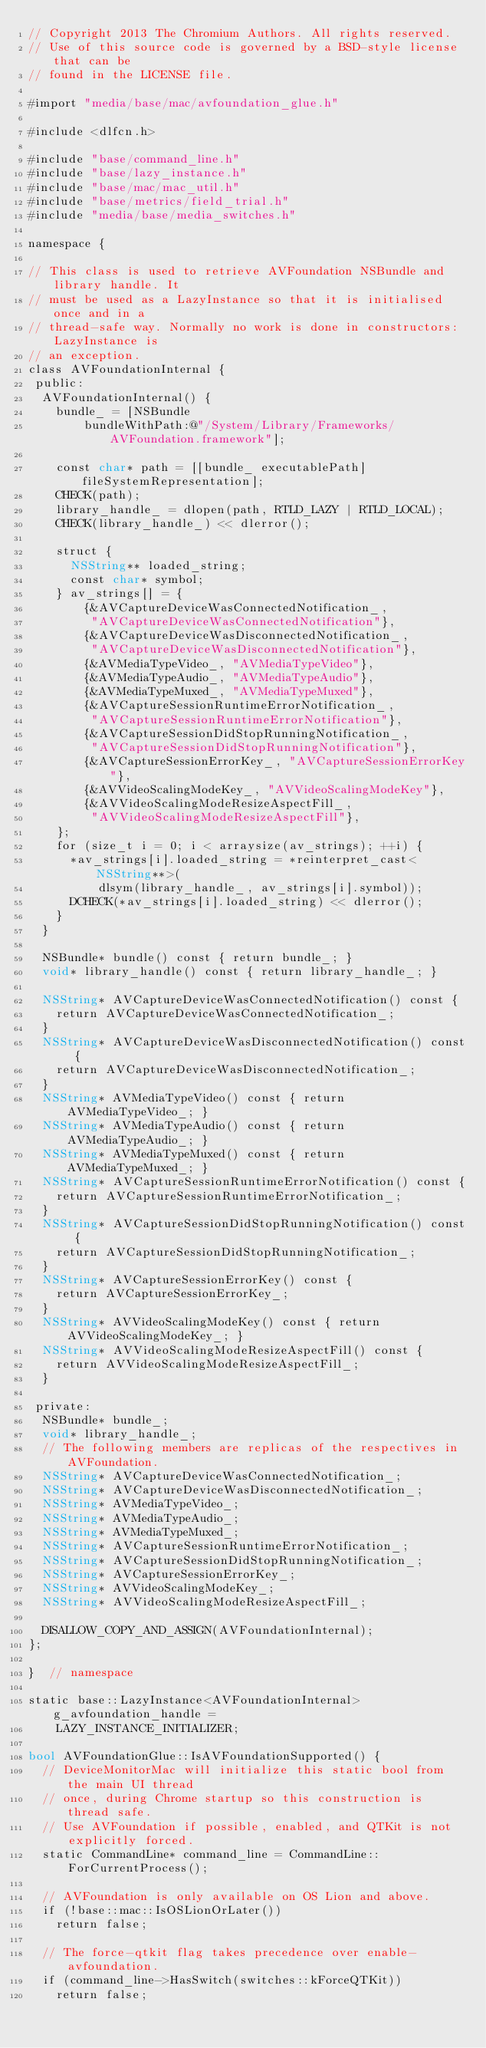<code> <loc_0><loc_0><loc_500><loc_500><_ObjectiveC_>// Copyright 2013 The Chromium Authors. All rights reserved.
// Use of this source code is governed by a BSD-style license that can be
// found in the LICENSE file.

#import "media/base/mac/avfoundation_glue.h"

#include <dlfcn.h>

#include "base/command_line.h"
#include "base/lazy_instance.h"
#include "base/mac/mac_util.h"
#include "base/metrics/field_trial.h"
#include "media/base/media_switches.h"

namespace {

// This class is used to retrieve AVFoundation NSBundle and library handle. It
// must be used as a LazyInstance so that it is initialised once and in a
// thread-safe way. Normally no work is done in constructors: LazyInstance is
// an exception.
class AVFoundationInternal {
 public:
  AVFoundationInternal() {
    bundle_ = [NSBundle
        bundleWithPath:@"/System/Library/Frameworks/AVFoundation.framework"];

    const char* path = [[bundle_ executablePath] fileSystemRepresentation];
    CHECK(path);
    library_handle_ = dlopen(path, RTLD_LAZY | RTLD_LOCAL);
    CHECK(library_handle_) << dlerror();

    struct {
      NSString** loaded_string;
      const char* symbol;
    } av_strings[] = {
        {&AVCaptureDeviceWasConnectedNotification_,
         "AVCaptureDeviceWasConnectedNotification"},
        {&AVCaptureDeviceWasDisconnectedNotification_,
         "AVCaptureDeviceWasDisconnectedNotification"},
        {&AVMediaTypeVideo_, "AVMediaTypeVideo"},
        {&AVMediaTypeAudio_, "AVMediaTypeAudio"},
        {&AVMediaTypeMuxed_, "AVMediaTypeMuxed"},
        {&AVCaptureSessionRuntimeErrorNotification_,
         "AVCaptureSessionRuntimeErrorNotification"},
        {&AVCaptureSessionDidStopRunningNotification_,
         "AVCaptureSessionDidStopRunningNotification"},
        {&AVCaptureSessionErrorKey_, "AVCaptureSessionErrorKey"},
        {&AVVideoScalingModeKey_, "AVVideoScalingModeKey"},
        {&AVVideoScalingModeResizeAspectFill_,
         "AVVideoScalingModeResizeAspectFill"},
    };
    for (size_t i = 0; i < arraysize(av_strings); ++i) {
      *av_strings[i].loaded_string = *reinterpret_cast<NSString**>(
          dlsym(library_handle_, av_strings[i].symbol));
      DCHECK(*av_strings[i].loaded_string) << dlerror();
    }
  }

  NSBundle* bundle() const { return bundle_; }
  void* library_handle() const { return library_handle_; }

  NSString* AVCaptureDeviceWasConnectedNotification() const {
    return AVCaptureDeviceWasConnectedNotification_;
  }
  NSString* AVCaptureDeviceWasDisconnectedNotification() const {
    return AVCaptureDeviceWasDisconnectedNotification_;
  }
  NSString* AVMediaTypeVideo() const { return AVMediaTypeVideo_; }
  NSString* AVMediaTypeAudio() const { return AVMediaTypeAudio_; }
  NSString* AVMediaTypeMuxed() const { return AVMediaTypeMuxed_; }
  NSString* AVCaptureSessionRuntimeErrorNotification() const {
    return AVCaptureSessionRuntimeErrorNotification_;
  }
  NSString* AVCaptureSessionDidStopRunningNotification() const {
    return AVCaptureSessionDidStopRunningNotification_;
  }
  NSString* AVCaptureSessionErrorKey() const {
    return AVCaptureSessionErrorKey_;
  }
  NSString* AVVideoScalingModeKey() const { return AVVideoScalingModeKey_; }
  NSString* AVVideoScalingModeResizeAspectFill() const {
    return AVVideoScalingModeResizeAspectFill_;
  }

 private:
  NSBundle* bundle_;
  void* library_handle_;
  // The following members are replicas of the respectives in AVFoundation.
  NSString* AVCaptureDeviceWasConnectedNotification_;
  NSString* AVCaptureDeviceWasDisconnectedNotification_;
  NSString* AVMediaTypeVideo_;
  NSString* AVMediaTypeAudio_;
  NSString* AVMediaTypeMuxed_;
  NSString* AVCaptureSessionRuntimeErrorNotification_;
  NSString* AVCaptureSessionDidStopRunningNotification_;
  NSString* AVCaptureSessionErrorKey_;
  NSString* AVVideoScalingModeKey_;
  NSString* AVVideoScalingModeResizeAspectFill_;

  DISALLOW_COPY_AND_ASSIGN(AVFoundationInternal);
};

}  // namespace

static base::LazyInstance<AVFoundationInternal> g_avfoundation_handle =
    LAZY_INSTANCE_INITIALIZER;

bool AVFoundationGlue::IsAVFoundationSupported() {
  // DeviceMonitorMac will initialize this static bool from the main UI thread
  // once, during Chrome startup so this construction is thread safe.
  // Use AVFoundation if possible, enabled, and QTKit is not explicitly forced.
  static CommandLine* command_line = CommandLine::ForCurrentProcess();

  // AVFoundation is only available on OS Lion and above.
  if (!base::mac::IsOSLionOrLater())
    return false;

  // The force-qtkit flag takes precedence over enable-avfoundation.
  if (command_line->HasSwitch(switches::kForceQTKit))
    return false;
</code> 